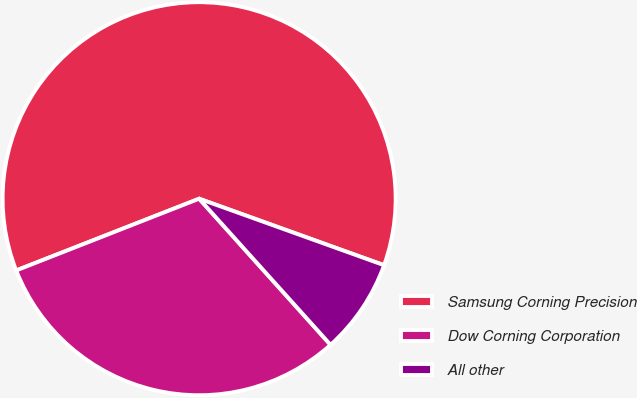Convert chart. <chart><loc_0><loc_0><loc_500><loc_500><pie_chart><fcel>Samsung Corning Precision<fcel>Dow Corning Corporation<fcel>All other<nl><fcel>61.44%<fcel>30.71%<fcel>7.85%<nl></chart> 